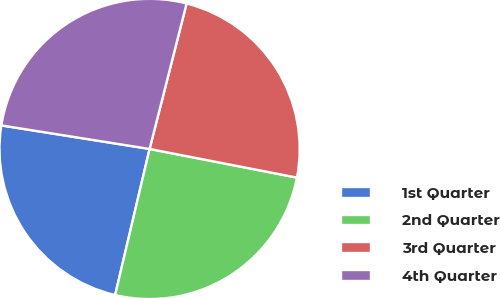Convert chart to OTSL. <chart><loc_0><loc_0><loc_500><loc_500><pie_chart><fcel>1st Quarter<fcel>2nd Quarter<fcel>3rd Quarter<fcel>4th Quarter<nl><fcel>23.82%<fcel>25.63%<fcel>24.09%<fcel>26.46%<nl></chart> 